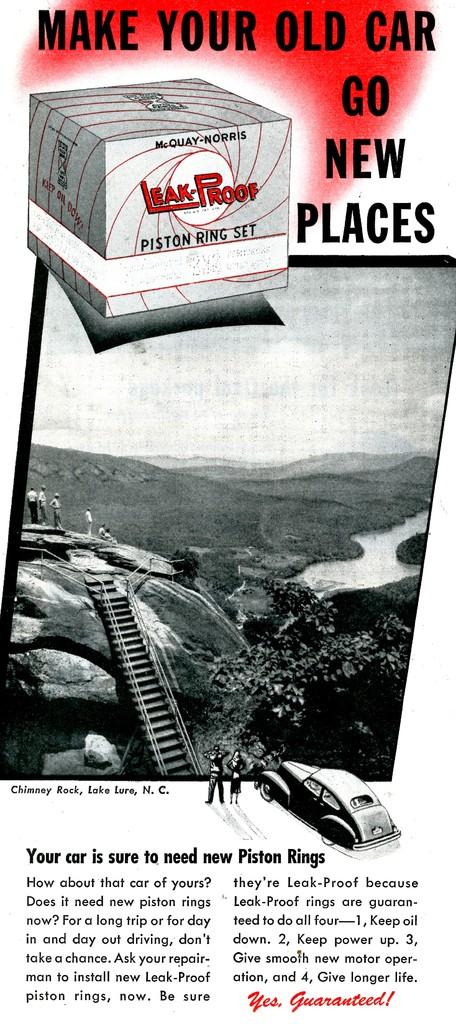What is the name of the company associated with this?
Make the answer very short. Mcquay-norris. Make your old car go where?
Provide a short and direct response. New places. 